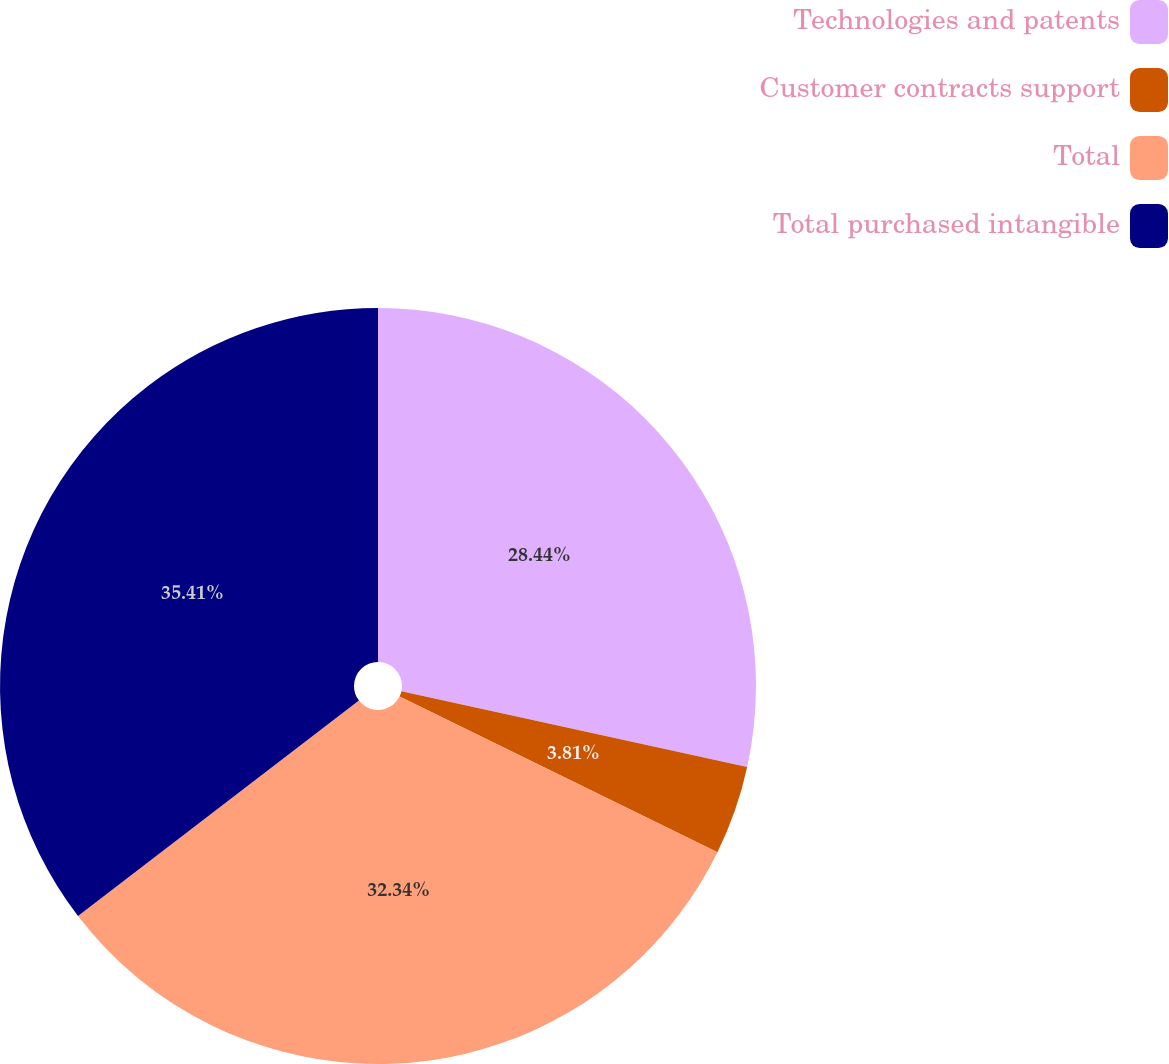<chart> <loc_0><loc_0><loc_500><loc_500><pie_chart><fcel>Technologies and patents<fcel>Customer contracts support<fcel>Total<fcel>Total purchased intangible<nl><fcel>28.44%<fcel>3.81%<fcel>32.34%<fcel>35.41%<nl></chart> 